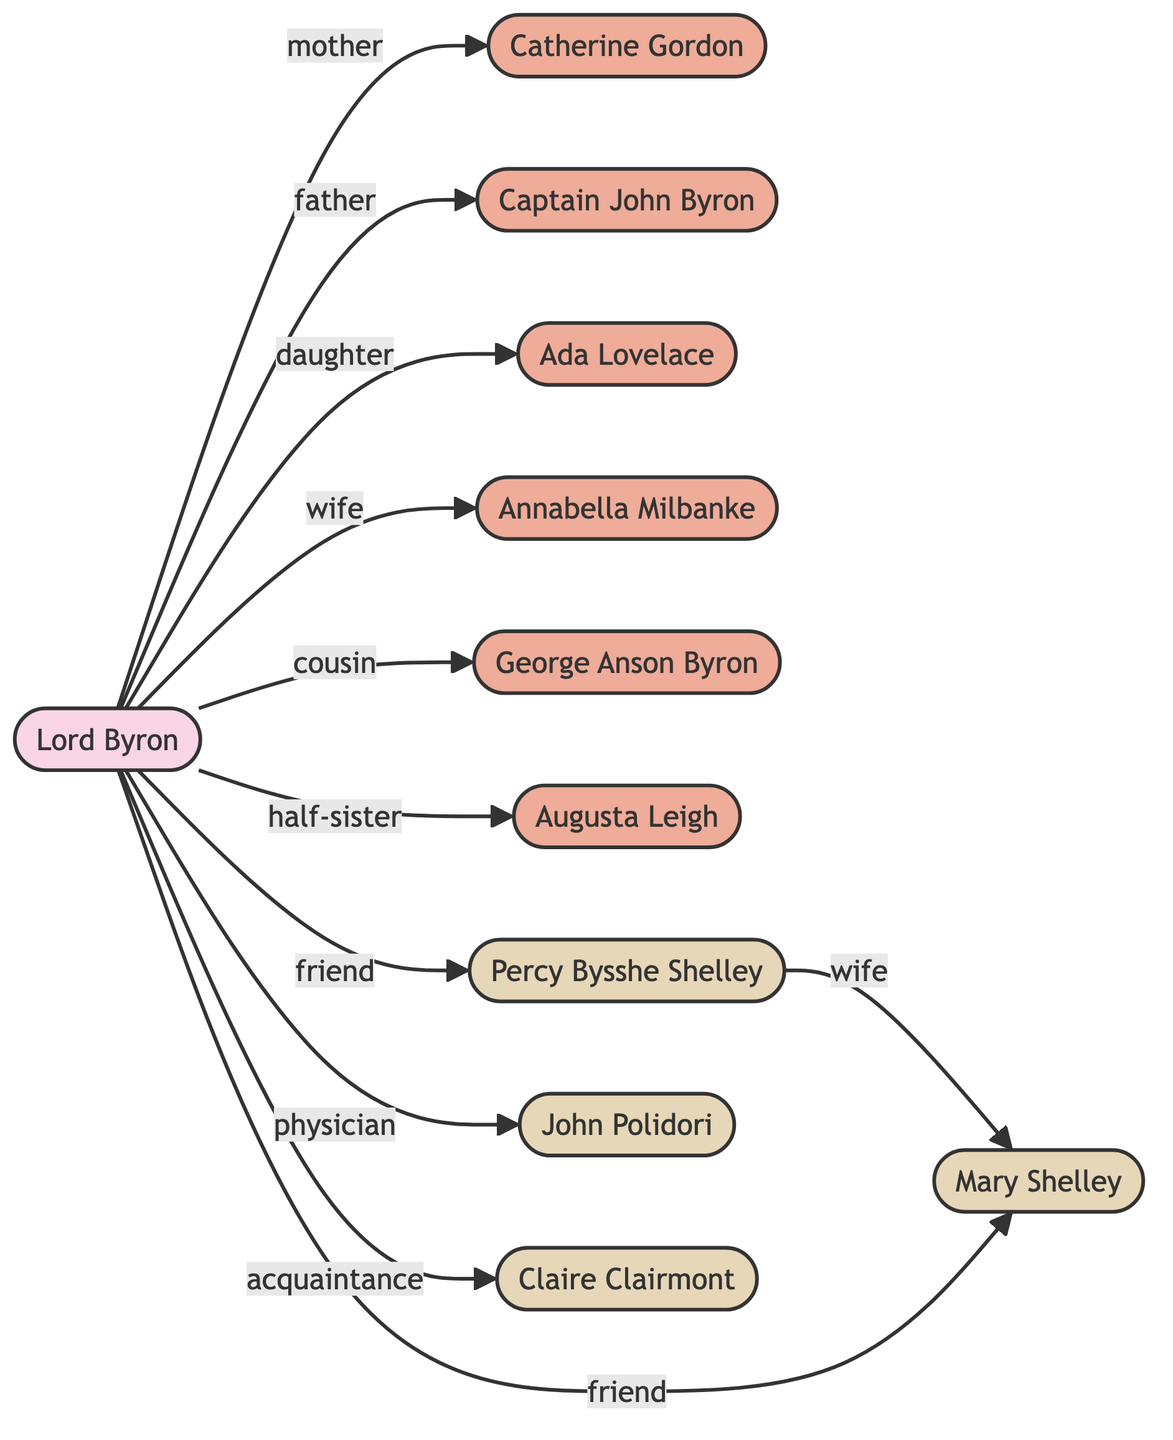What is the relationship between Lord Byron and Ada Lovelace? The diagram shows that Lord Byron is connected to Ada Lovelace with the label "daughter", indicating that she is his child.
Answer: daughter Who is the mother of Lord Byron? The diagram indicates that Lord Byron has a connection to Catherine Gordon labeled as "mother", establishing her as his mother.
Answer: Catherine Gordon How many notable acquaintances does Lord Byron have shown in the diagram? By counting the edges connected to Lord Byron that have the label indicating friendship or acquaintance, we find that there are four notable acquaintances: Percy Bysshe Shelley, Mary Shelley, John Polidori, and Claire Clairmont.
Answer: 4 What is the relationship between Percy Bysshe Shelley and Mary Shelley? The diagram displays a connection between Percy Bysshe Shelley and Mary Shelley with the label "wife", indicating their marital relationship.
Answer: wife What is Lord Byron's relationship to Augusta Leigh? The connection from Lord Byron to Augusta Leigh is labeled "half-sister", defining their familial relationship.
Answer: half-sister Who is the cousin of Lord Byron? The diagram shows that George Anson Byron is connected to Lord Byron with the label "cousin", indicating their familial relationship.
Answer: George Anson Byron How many edges are in the diagram? By counting each connection depicted in the diagram, we determine there are 10 edges representing relationships, such as familial ties, friendships, and acquaintances.
Answer: 10 Which two individuals in the diagram are connected as friends? The edges labeled "friend" connect Lord Byron to Percy Bysshe Shelley and Lord Byron to Mary Shelley, indicating their friendships.
Answer: Percy Bysshe Shelley and Mary Shelley Who is the father of Lord Byron? According to the diagram, Captain John Byron is connected to Lord Byron with the label "father", establishing him as Lord Byron's father.
Answer: Captain John Byron 